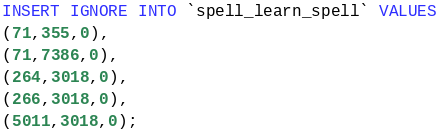<code> <loc_0><loc_0><loc_500><loc_500><_SQL_>INSERT IGNORE INTO `spell_learn_spell` VALUES
(71,355,0),
(71,7386,0),
(264,3018,0),
(266,3018,0),
(5011,3018,0);
</code> 